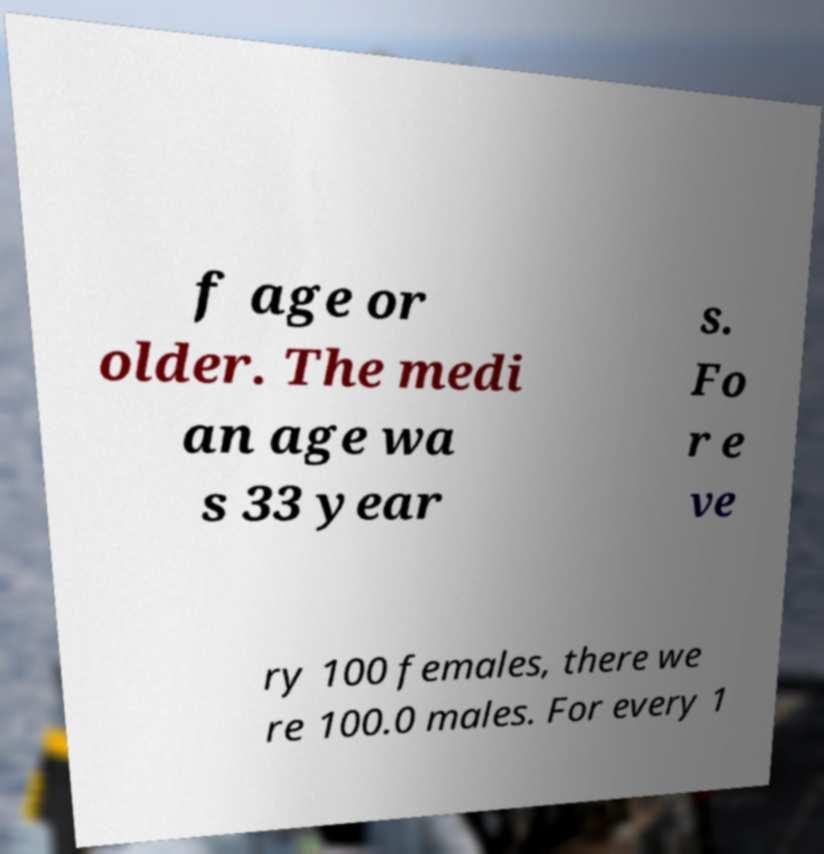Could you extract and type out the text from this image? f age or older. The medi an age wa s 33 year s. Fo r e ve ry 100 females, there we re 100.0 males. For every 1 